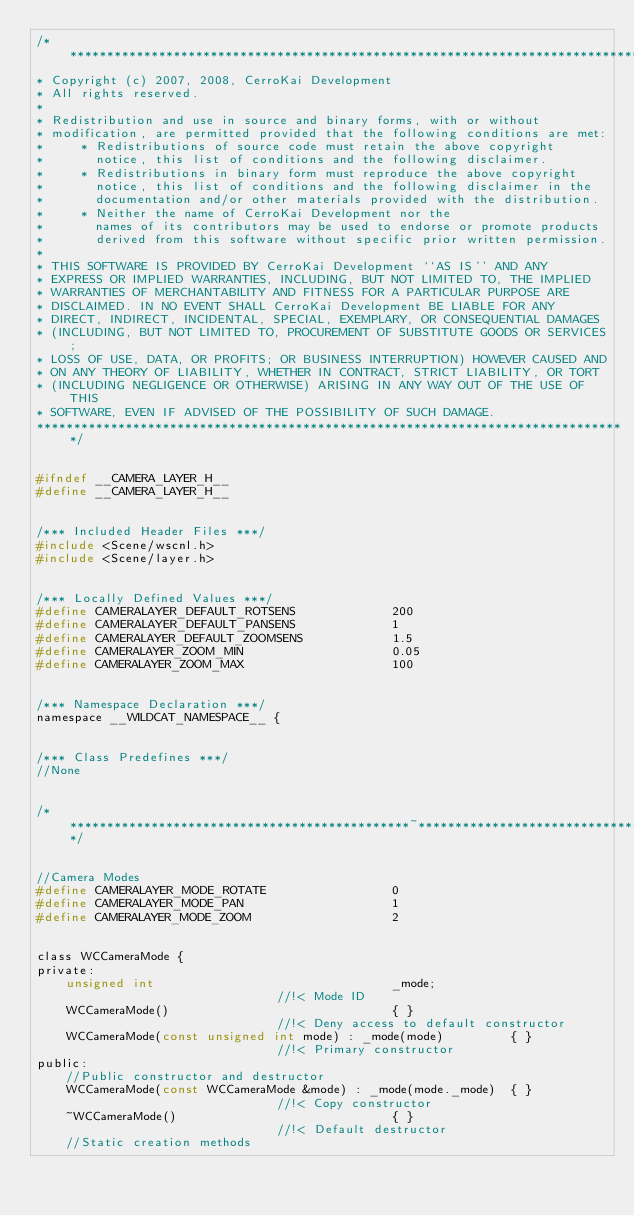Convert code to text. <code><loc_0><loc_0><loc_500><loc_500><_C_>/*******************************************************************************
* Copyright (c) 2007, 2008, CerroKai Development
* All rights reserved.
*
* Redistribution and use in source and binary forms, with or without
* modification, are permitted provided that the following conditions are met:
*     * Redistributions of source code must retain the above copyright
*       notice, this list of conditions and the following disclaimer.
*     * Redistributions in binary form must reproduce the above copyright
*       notice, this list of conditions and the following disclaimer in the
*       documentation and/or other materials provided with the distribution.
*     * Neither the name of CerroKai Development nor the
*       names of its contributors may be used to endorse or promote products
*       derived from this software without specific prior written permission.
*
* THIS SOFTWARE IS PROVIDED BY CerroKai Development ``AS IS'' AND ANY
* EXPRESS OR IMPLIED WARRANTIES, INCLUDING, BUT NOT LIMITED TO, THE IMPLIED
* WARRANTIES OF MERCHANTABILITY AND FITNESS FOR A PARTICULAR PURPOSE ARE
* DISCLAIMED. IN NO EVENT SHALL CerroKai Development BE LIABLE FOR ANY
* DIRECT, INDIRECT, INCIDENTAL, SPECIAL, EXEMPLARY, OR CONSEQUENTIAL DAMAGES
* (INCLUDING, BUT NOT LIMITED TO, PROCUREMENT OF SUBSTITUTE GOODS OR SERVICES;
* LOSS OF USE, DATA, OR PROFITS; OR BUSINESS INTERRUPTION) HOWEVER CAUSED AND
* ON ANY THEORY OF LIABILITY, WHETHER IN CONTRACT, STRICT LIABILITY, OR TORT
* (INCLUDING NEGLIGENCE OR OTHERWISE) ARISING IN ANY WAY OUT OF THE USE OF THIS
* SOFTWARE, EVEN IF ADVISED OF THE POSSIBILITY OF SUCH DAMAGE.
********************************************************************************/


#ifndef __CAMERA_LAYER_H__
#define __CAMERA_LAYER_H__


/*** Included Header Files ***/
#include <Scene/wscnl.h>
#include <Scene/layer.h>


/*** Locally Defined Values ***/
#define CAMERALAYER_DEFAULT_ROTSENS				200
#define CAMERALAYER_DEFAULT_PANSENS				1
#define CAMERALAYER_DEFAULT_ZOOMSENS			1.5
#define CAMERALAYER_ZOOM_MIN					0.05
#define CAMERALAYER_ZOOM_MAX					100


/*** Namespace Declaration ***/
namespace __WILDCAT_NAMESPACE__ {


/*** Class Predefines ***/
//None


/***********************************************~***************************************************/


//Camera Modes
#define CAMERALAYER_MODE_ROTATE					0
#define CAMERALAYER_MODE_PAN					1
#define CAMERALAYER_MODE_ZOOM					2


class WCCameraMode {
private:
	unsigned int								_mode;												//!< Mode ID
	WCCameraMode()								{ }													//!< Deny access to default constructor
	WCCameraMode(const unsigned int mode) : _mode(mode)			{ }									//!< Primary constructor
public:
	//Public constructor and destructor
	WCCameraMode(const WCCameraMode &mode) : _mode(mode._mode)	{ }									//!< Copy constructor
	~WCCameraMode()								{ }													//!< Default destructor
	//Static creation methods</code> 